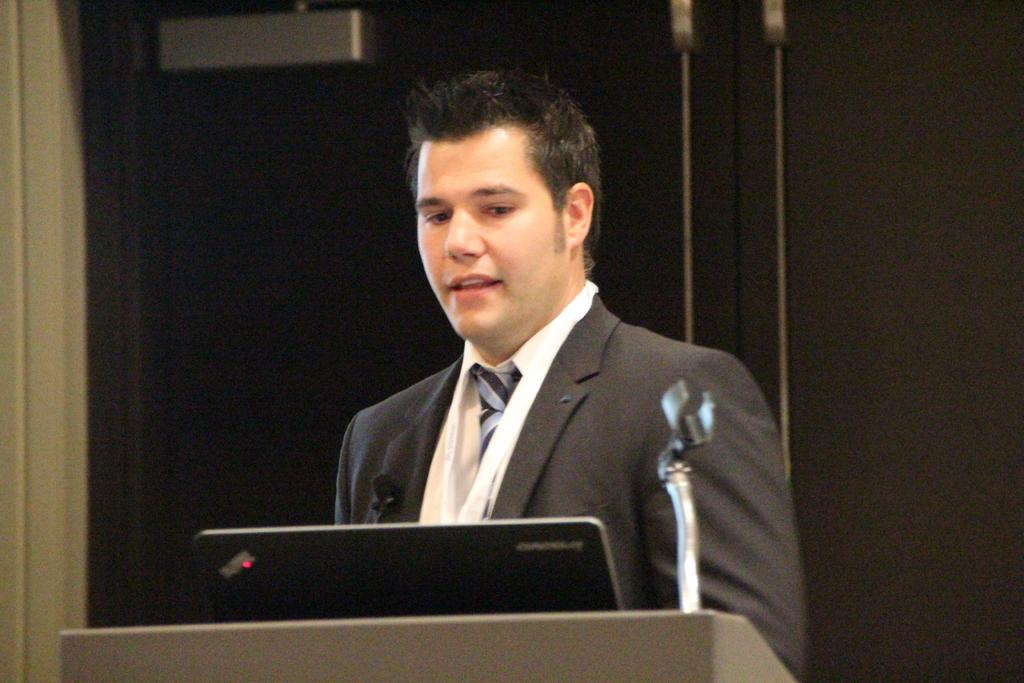What is the person in the image doing? The person is standing in front of the podium. What objects are on the podium? There is a laptop and a microphone on the podium. What can be seen behind the person and the podium? The background appears to be a wall. How many apples are on the person's suit in the image? There are no apples or suits present in the image. Can you describe the deer in the background of the image? There are no deer present in the image; the background is a wall. 